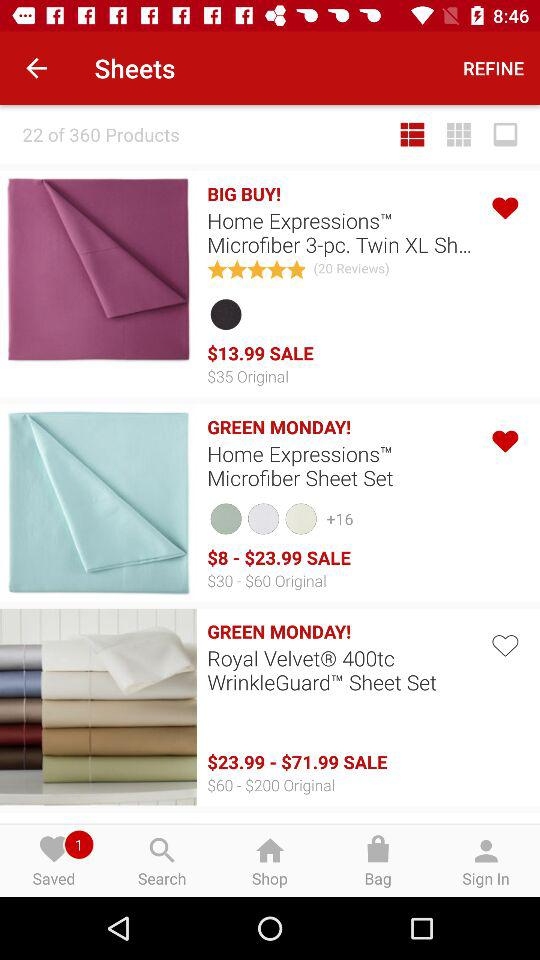Which item is not liked by the user? The item that is not liked by the user is "Royal Velvet® 400tc WrinkleGuard™ Sheet Set". 